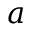Convert formula to latex. <formula><loc_0><loc_0><loc_500><loc_500>a</formula> 